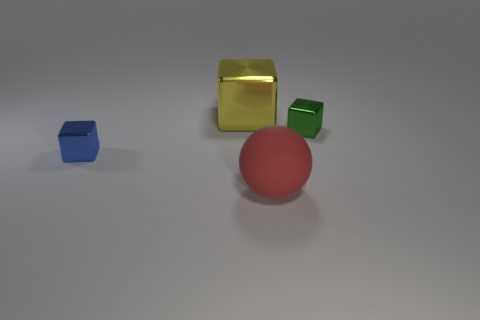Subtract all purple blocks. Subtract all brown balls. How many blocks are left? 3 Add 4 tiny cyan shiny objects. How many objects exist? 8 Subtract all blocks. How many objects are left? 1 Add 1 green metallic blocks. How many green metallic blocks are left? 2 Add 4 large metallic blocks. How many large metallic blocks exist? 5 Subtract 1 red spheres. How many objects are left? 3 Subtract all yellow metal things. Subtract all cyan shiny blocks. How many objects are left? 3 